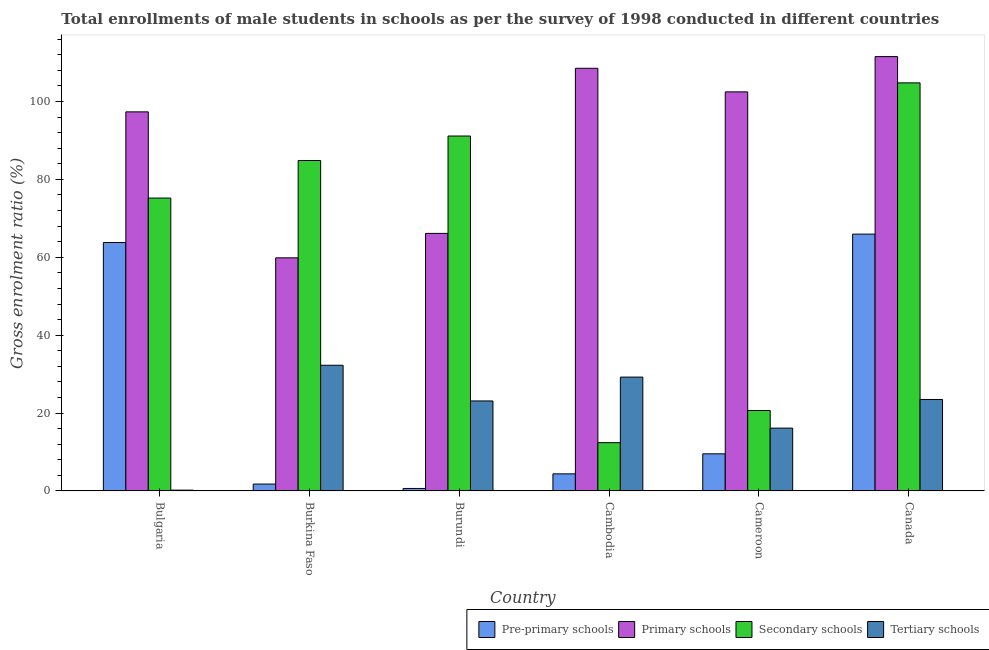How many different coloured bars are there?
Offer a terse response. 4. Are the number of bars on each tick of the X-axis equal?
Your answer should be compact. Yes. How many bars are there on the 3rd tick from the left?
Provide a short and direct response. 4. How many bars are there on the 6th tick from the right?
Your answer should be very brief. 4. What is the label of the 3rd group of bars from the left?
Your response must be concise. Burundi. In how many cases, is the number of bars for a given country not equal to the number of legend labels?
Your answer should be compact. 0. What is the gross enrolment ratio(male) in tertiary schools in Bulgaria?
Your answer should be very brief. 0.2. Across all countries, what is the maximum gross enrolment ratio(male) in tertiary schools?
Offer a very short reply. 32.27. Across all countries, what is the minimum gross enrolment ratio(male) in secondary schools?
Give a very brief answer. 12.4. In which country was the gross enrolment ratio(male) in pre-primary schools minimum?
Give a very brief answer. Burundi. What is the total gross enrolment ratio(male) in primary schools in the graph?
Ensure brevity in your answer.  545.9. What is the difference between the gross enrolment ratio(male) in pre-primary schools in Cambodia and that in Cameroon?
Your answer should be very brief. -5.14. What is the difference between the gross enrolment ratio(male) in pre-primary schools in Cambodia and the gross enrolment ratio(male) in primary schools in Burkina Faso?
Offer a terse response. -55.47. What is the average gross enrolment ratio(male) in tertiary schools per country?
Offer a very short reply. 20.74. What is the difference between the gross enrolment ratio(male) in pre-primary schools and gross enrolment ratio(male) in tertiary schools in Canada?
Offer a very short reply. 42.46. In how many countries, is the gross enrolment ratio(male) in pre-primary schools greater than 24 %?
Give a very brief answer. 2. What is the ratio of the gross enrolment ratio(male) in pre-primary schools in Burundi to that in Cambodia?
Provide a succinct answer. 0.15. Is the difference between the gross enrolment ratio(male) in pre-primary schools in Burundi and Cambodia greater than the difference between the gross enrolment ratio(male) in primary schools in Burundi and Cambodia?
Make the answer very short. Yes. What is the difference between the highest and the second highest gross enrolment ratio(male) in pre-primary schools?
Your answer should be very brief. 2.16. What is the difference between the highest and the lowest gross enrolment ratio(male) in primary schools?
Provide a succinct answer. 51.68. Is the sum of the gross enrolment ratio(male) in secondary schools in Burkina Faso and Burundi greater than the maximum gross enrolment ratio(male) in primary schools across all countries?
Make the answer very short. Yes. Is it the case that in every country, the sum of the gross enrolment ratio(male) in secondary schools and gross enrolment ratio(male) in primary schools is greater than the sum of gross enrolment ratio(male) in tertiary schools and gross enrolment ratio(male) in pre-primary schools?
Keep it short and to the point. No. What does the 1st bar from the left in Burkina Faso represents?
Ensure brevity in your answer.  Pre-primary schools. What does the 2nd bar from the right in Cambodia represents?
Provide a succinct answer. Secondary schools. Is it the case that in every country, the sum of the gross enrolment ratio(male) in pre-primary schools and gross enrolment ratio(male) in primary schools is greater than the gross enrolment ratio(male) in secondary schools?
Offer a very short reply. No. How many bars are there?
Your answer should be very brief. 24. How many countries are there in the graph?
Your answer should be very brief. 6. What is the difference between two consecutive major ticks on the Y-axis?
Make the answer very short. 20. Does the graph contain any zero values?
Ensure brevity in your answer.  No. Does the graph contain grids?
Your answer should be very brief. No. Where does the legend appear in the graph?
Your response must be concise. Bottom right. How many legend labels are there?
Offer a very short reply. 4. How are the legend labels stacked?
Keep it short and to the point. Horizontal. What is the title of the graph?
Your response must be concise. Total enrollments of male students in schools as per the survey of 1998 conducted in different countries. Does "Arable land" appear as one of the legend labels in the graph?
Your response must be concise. No. What is the label or title of the X-axis?
Make the answer very short. Country. What is the label or title of the Y-axis?
Give a very brief answer. Gross enrolment ratio (%). What is the Gross enrolment ratio (%) in Pre-primary schools in Bulgaria?
Provide a short and direct response. 63.8. What is the Gross enrolment ratio (%) of Primary schools in Bulgaria?
Your response must be concise. 97.35. What is the Gross enrolment ratio (%) of Secondary schools in Bulgaria?
Ensure brevity in your answer.  75.21. What is the Gross enrolment ratio (%) of Tertiary schools in Bulgaria?
Provide a short and direct response. 0.2. What is the Gross enrolment ratio (%) of Pre-primary schools in Burkina Faso?
Keep it short and to the point. 1.77. What is the Gross enrolment ratio (%) in Primary schools in Burkina Faso?
Make the answer very short. 59.86. What is the Gross enrolment ratio (%) of Secondary schools in Burkina Faso?
Provide a succinct answer. 84.85. What is the Gross enrolment ratio (%) in Tertiary schools in Burkina Faso?
Provide a succinct answer. 32.27. What is the Gross enrolment ratio (%) of Pre-primary schools in Burundi?
Your response must be concise. 0.64. What is the Gross enrolment ratio (%) of Primary schools in Burundi?
Ensure brevity in your answer.  66.14. What is the Gross enrolment ratio (%) in Secondary schools in Burundi?
Offer a terse response. 91.14. What is the Gross enrolment ratio (%) in Tertiary schools in Burundi?
Provide a short and direct response. 23.11. What is the Gross enrolment ratio (%) of Pre-primary schools in Cambodia?
Offer a terse response. 4.39. What is the Gross enrolment ratio (%) in Primary schools in Cambodia?
Provide a short and direct response. 108.53. What is the Gross enrolment ratio (%) in Secondary schools in Cambodia?
Your response must be concise. 12.4. What is the Gross enrolment ratio (%) of Tertiary schools in Cambodia?
Keep it short and to the point. 29.23. What is the Gross enrolment ratio (%) in Pre-primary schools in Cameroon?
Provide a short and direct response. 9.53. What is the Gross enrolment ratio (%) of Primary schools in Cameroon?
Provide a short and direct response. 102.48. What is the Gross enrolment ratio (%) in Secondary schools in Cameroon?
Your response must be concise. 20.66. What is the Gross enrolment ratio (%) in Tertiary schools in Cameroon?
Offer a terse response. 16.13. What is the Gross enrolment ratio (%) of Pre-primary schools in Canada?
Ensure brevity in your answer.  65.95. What is the Gross enrolment ratio (%) in Primary schools in Canada?
Make the answer very short. 111.54. What is the Gross enrolment ratio (%) of Secondary schools in Canada?
Make the answer very short. 104.79. What is the Gross enrolment ratio (%) of Tertiary schools in Canada?
Give a very brief answer. 23.49. Across all countries, what is the maximum Gross enrolment ratio (%) in Pre-primary schools?
Offer a very short reply. 65.95. Across all countries, what is the maximum Gross enrolment ratio (%) of Primary schools?
Ensure brevity in your answer.  111.54. Across all countries, what is the maximum Gross enrolment ratio (%) in Secondary schools?
Offer a very short reply. 104.79. Across all countries, what is the maximum Gross enrolment ratio (%) of Tertiary schools?
Keep it short and to the point. 32.27. Across all countries, what is the minimum Gross enrolment ratio (%) in Pre-primary schools?
Make the answer very short. 0.64. Across all countries, what is the minimum Gross enrolment ratio (%) in Primary schools?
Ensure brevity in your answer.  59.86. Across all countries, what is the minimum Gross enrolment ratio (%) of Secondary schools?
Give a very brief answer. 12.4. Across all countries, what is the minimum Gross enrolment ratio (%) of Tertiary schools?
Provide a short and direct response. 0.2. What is the total Gross enrolment ratio (%) of Pre-primary schools in the graph?
Provide a short and direct response. 146.08. What is the total Gross enrolment ratio (%) in Primary schools in the graph?
Offer a very short reply. 545.9. What is the total Gross enrolment ratio (%) of Secondary schools in the graph?
Keep it short and to the point. 389.05. What is the total Gross enrolment ratio (%) of Tertiary schools in the graph?
Provide a short and direct response. 124.44. What is the difference between the Gross enrolment ratio (%) of Pre-primary schools in Bulgaria and that in Burkina Faso?
Provide a succinct answer. 62.03. What is the difference between the Gross enrolment ratio (%) of Primary schools in Bulgaria and that in Burkina Faso?
Ensure brevity in your answer.  37.48. What is the difference between the Gross enrolment ratio (%) of Secondary schools in Bulgaria and that in Burkina Faso?
Offer a terse response. -9.64. What is the difference between the Gross enrolment ratio (%) of Tertiary schools in Bulgaria and that in Burkina Faso?
Keep it short and to the point. -32.07. What is the difference between the Gross enrolment ratio (%) of Pre-primary schools in Bulgaria and that in Burundi?
Offer a terse response. 63.16. What is the difference between the Gross enrolment ratio (%) of Primary schools in Bulgaria and that in Burundi?
Ensure brevity in your answer.  31.21. What is the difference between the Gross enrolment ratio (%) of Secondary schools in Bulgaria and that in Burundi?
Offer a very short reply. -15.93. What is the difference between the Gross enrolment ratio (%) of Tertiary schools in Bulgaria and that in Burundi?
Make the answer very short. -22.91. What is the difference between the Gross enrolment ratio (%) in Pre-primary schools in Bulgaria and that in Cambodia?
Your response must be concise. 59.41. What is the difference between the Gross enrolment ratio (%) in Primary schools in Bulgaria and that in Cambodia?
Make the answer very short. -11.19. What is the difference between the Gross enrolment ratio (%) in Secondary schools in Bulgaria and that in Cambodia?
Your response must be concise. 62.82. What is the difference between the Gross enrolment ratio (%) of Tertiary schools in Bulgaria and that in Cambodia?
Your answer should be compact. -29.03. What is the difference between the Gross enrolment ratio (%) in Pre-primary schools in Bulgaria and that in Cameroon?
Provide a succinct answer. 54.26. What is the difference between the Gross enrolment ratio (%) in Primary schools in Bulgaria and that in Cameroon?
Provide a succinct answer. -5.13. What is the difference between the Gross enrolment ratio (%) in Secondary schools in Bulgaria and that in Cameroon?
Your response must be concise. 54.55. What is the difference between the Gross enrolment ratio (%) of Tertiary schools in Bulgaria and that in Cameroon?
Your answer should be very brief. -15.93. What is the difference between the Gross enrolment ratio (%) of Pre-primary schools in Bulgaria and that in Canada?
Offer a terse response. -2.16. What is the difference between the Gross enrolment ratio (%) in Primary schools in Bulgaria and that in Canada?
Offer a terse response. -14.19. What is the difference between the Gross enrolment ratio (%) of Secondary schools in Bulgaria and that in Canada?
Your answer should be compact. -29.58. What is the difference between the Gross enrolment ratio (%) in Tertiary schools in Bulgaria and that in Canada?
Ensure brevity in your answer.  -23.29. What is the difference between the Gross enrolment ratio (%) of Pre-primary schools in Burkina Faso and that in Burundi?
Offer a very short reply. 1.13. What is the difference between the Gross enrolment ratio (%) of Primary schools in Burkina Faso and that in Burundi?
Your answer should be compact. -6.27. What is the difference between the Gross enrolment ratio (%) of Secondary schools in Burkina Faso and that in Burundi?
Offer a terse response. -6.29. What is the difference between the Gross enrolment ratio (%) of Tertiary schools in Burkina Faso and that in Burundi?
Your response must be concise. 9.16. What is the difference between the Gross enrolment ratio (%) of Pre-primary schools in Burkina Faso and that in Cambodia?
Your answer should be compact. -2.62. What is the difference between the Gross enrolment ratio (%) of Primary schools in Burkina Faso and that in Cambodia?
Make the answer very short. -48.67. What is the difference between the Gross enrolment ratio (%) in Secondary schools in Burkina Faso and that in Cambodia?
Your response must be concise. 72.46. What is the difference between the Gross enrolment ratio (%) in Tertiary schools in Burkina Faso and that in Cambodia?
Your answer should be compact. 3.04. What is the difference between the Gross enrolment ratio (%) of Pre-primary schools in Burkina Faso and that in Cameroon?
Offer a very short reply. -7.77. What is the difference between the Gross enrolment ratio (%) in Primary schools in Burkina Faso and that in Cameroon?
Your response must be concise. -42.62. What is the difference between the Gross enrolment ratio (%) in Secondary schools in Burkina Faso and that in Cameroon?
Your response must be concise. 64.2. What is the difference between the Gross enrolment ratio (%) of Tertiary schools in Burkina Faso and that in Cameroon?
Keep it short and to the point. 16.14. What is the difference between the Gross enrolment ratio (%) of Pre-primary schools in Burkina Faso and that in Canada?
Give a very brief answer. -64.18. What is the difference between the Gross enrolment ratio (%) in Primary schools in Burkina Faso and that in Canada?
Offer a terse response. -51.68. What is the difference between the Gross enrolment ratio (%) in Secondary schools in Burkina Faso and that in Canada?
Offer a very short reply. -19.94. What is the difference between the Gross enrolment ratio (%) of Tertiary schools in Burkina Faso and that in Canada?
Your response must be concise. 8.79. What is the difference between the Gross enrolment ratio (%) in Pre-primary schools in Burundi and that in Cambodia?
Make the answer very short. -3.75. What is the difference between the Gross enrolment ratio (%) in Primary schools in Burundi and that in Cambodia?
Give a very brief answer. -42.4. What is the difference between the Gross enrolment ratio (%) of Secondary schools in Burundi and that in Cambodia?
Ensure brevity in your answer.  78.74. What is the difference between the Gross enrolment ratio (%) in Tertiary schools in Burundi and that in Cambodia?
Give a very brief answer. -6.12. What is the difference between the Gross enrolment ratio (%) in Pre-primary schools in Burundi and that in Cameroon?
Your answer should be very brief. -8.9. What is the difference between the Gross enrolment ratio (%) in Primary schools in Burundi and that in Cameroon?
Your answer should be very brief. -36.34. What is the difference between the Gross enrolment ratio (%) of Secondary schools in Burundi and that in Cameroon?
Your answer should be very brief. 70.48. What is the difference between the Gross enrolment ratio (%) of Tertiary schools in Burundi and that in Cameroon?
Provide a short and direct response. 6.98. What is the difference between the Gross enrolment ratio (%) of Pre-primary schools in Burundi and that in Canada?
Offer a very short reply. -65.31. What is the difference between the Gross enrolment ratio (%) of Primary schools in Burundi and that in Canada?
Provide a succinct answer. -45.4. What is the difference between the Gross enrolment ratio (%) of Secondary schools in Burundi and that in Canada?
Offer a terse response. -13.65. What is the difference between the Gross enrolment ratio (%) in Tertiary schools in Burundi and that in Canada?
Keep it short and to the point. -0.38. What is the difference between the Gross enrolment ratio (%) of Pre-primary schools in Cambodia and that in Cameroon?
Provide a succinct answer. -5.14. What is the difference between the Gross enrolment ratio (%) of Primary schools in Cambodia and that in Cameroon?
Offer a very short reply. 6.05. What is the difference between the Gross enrolment ratio (%) of Secondary schools in Cambodia and that in Cameroon?
Offer a terse response. -8.26. What is the difference between the Gross enrolment ratio (%) of Tertiary schools in Cambodia and that in Cameroon?
Give a very brief answer. 13.1. What is the difference between the Gross enrolment ratio (%) of Pre-primary schools in Cambodia and that in Canada?
Provide a succinct answer. -61.56. What is the difference between the Gross enrolment ratio (%) of Primary schools in Cambodia and that in Canada?
Your answer should be compact. -3. What is the difference between the Gross enrolment ratio (%) of Secondary schools in Cambodia and that in Canada?
Offer a very short reply. -92.4. What is the difference between the Gross enrolment ratio (%) of Tertiary schools in Cambodia and that in Canada?
Make the answer very short. 5.74. What is the difference between the Gross enrolment ratio (%) in Pre-primary schools in Cameroon and that in Canada?
Ensure brevity in your answer.  -56.42. What is the difference between the Gross enrolment ratio (%) of Primary schools in Cameroon and that in Canada?
Keep it short and to the point. -9.06. What is the difference between the Gross enrolment ratio (%) of Secondary schools in Cameroon and that in Canada?
Offer a very short reply. -84.13. What is the difference between the Gross enrolment ratio (%) of Tertiary schools in Cameroon and that in Canada?
Your response must be concise. -7.36. What is the difference between the Gross enrolment ratio (%) in Pre-primary schools in Bulgaria and the Gross enrolment ratio (%) in Primary schools in Burkina Faso?
Offer a terse response. 3.94. What is the difference between the Gross enrolment ratio (%) of Pre-primary schools in Bulgaria and the Gross enrolment ratio (%) of Secondary schools in Burkina Faso?
Make the answer very short. -21.06. What is the difference between the Gross enrolment ratio (%) in Pre-primary schools in Bulgaria and the Gross enrolment ratio (%) in Tertiary schools in Burkina Faso?
Keep it short and to the point. 31.52. What is the difference between the Gross enrolment ratio (%) of Primary schools in Bulgaria and the Gross enrolment ratio (%) of Secondary schools in Burkina Faso?
Your response must be concise. 12.49. What is the difference between the Gross enrolment ratio (%) of Primary schools in Bulgaria and the Gross enrolment ratio (%) of Tertiary schools in Burkina Faso?
Keep it short and to the point. 65.07. What is the difference between the Gross enrolment ratio (%) of Secondary schools in Bulgaria and the Gross enrolment ratio (%) of Tertiary schools in Burkina Faso?
Provide a short and direct response. 42.94. What is the difference between the Gross enrolment ratio (%) of Pre-primary schools in Bulgaria and the Gross enrolment ratio (%) of Primary schools in Burundi?
Make the answer very short. -2.34. What is the difference between the Gross enrolment ratio (%) in Pre-primary schools in Bulgaria and the Gross enrolment ratio (%) in Secondary schools in Burundi?
Provide a short and direct response. -27.34. What is the difference between the Gross enrolment ratio (%) in Pre-primary schools in Bulgaria and the Gross enrolment ratio (%) in Tertiary schools in Burundi?
Offer a very short reply. 40.69. What is the difference between the Gross enrolment ratio (%) of Primary schools in Bulgaria and the Gross enrolment ratio (%) of Secondary schools in Burundi?
Give a very brief answer. 6.21. What is the difference between the Gross enrolment ratio (%) in Primary schools in Bulgaria and the Gross enrolment ratio (%) in Tertiary schools in Burundi?
Provide a succinct answer. 74.24. What is the difference between the Gross enrolment ratio (%) in Secondary schools in Bulgaria and the Gross enrolment ratio (%) in Tertiary schools in Burundi?
Your response must be concise. 52.1. What is the difference between the Gross enrolment ratio (%) of Pre-primary schools in Bulgaria and the Gross enrolment ratio (%) of Primary schools in Cambodia?
Make the answer very short. -44.74. What is the difference between the Gross enrolment ratio (%) in Pre-primary schools in Bulgaria and the Gross enrolment ratio (%) in Secondary schools in Cambodia?
Provide a succinct answer. 51.4. What is the difference between the Gross enrolment ratio (%) of Pre-primary schools in Bulgaria and the Gross enrolment ratio (%) of Tertiary schools in Cambodia?
Offer a very short reply. 34.57. What is the difference between the Gross enrolment ratio (%) of Primary schools in Bulgaria and the Gross enrolment ratio (%) of Secondary schools in Cambodia?
Provide a succinct answer. 84.95. What is the difference between the Gross enrolment ratio (%) of Primary schools in Bulgaria and the Gross enrolment ratio (%) of Tertiary schools in Cambodia?
Give a very brief answer. 68.11. What is the difference between the Gross enrolment ratio (%) in Secondary schools in Bulgaria and the Gross enrolment ratio (%) in Tertiary schools in Cambodia?
Ensure brevity in your answer.  45.98. What is the difference between the Gross enrolment ratio (%) of Pre-primary schools in Bulgaria and the Gross enrolment ratio (%) of Primary schools in Cameroon?
Your answer should be compact. -38.68. What is the difference between the Gross enrolment ratio (%) of Pre-primary schools in Bulgaria and the Gross enrolment ratio (%) of Secondary schools in Cameroon?
Your answer should be compact. 43.14. What is the difference between the Gross enrolment ratio (%) of Pre-primary schools in Bulgaria and the Gross enrolment ratio (%) of Tertiary schools in Cameroon?
Provide a succinct answer. 47.67. What is the difference between the Gross enrolment ratio (%) of Primary schools in Bulgaria and the Gross enrolment ratio (%) of Secondary schools in Cameroon?
Provide a short and direct response. 76.69. What is the difference between the Gross enrolment ratio (%) of Primary schools in Bulgaria and the Gross enrolment ratio (%) of Tertiary schools in Cameroon?
Your answer should be compact. 81.21. What is the difference between the Gross enrolment ratio (%) in Secondary schools in Bulgaria and the Gross enrolment ratio (%) in Tertiary schools in Cameroon?
Provide a succinct answer. 59.08. What is the difference between the Gross enrolment ratio (%) in Pre-primary schools in Bulgaria and the Gross enrolment ratio (%) in Primary schools in Canada?
Provide a short and direct response. -47.74. What is the difference between the Gross enrolment ratio (%) in Pre-primary schools in Bulgaria and the Gross enrolment ratio (%) in Secondary schools in Canada?
Provide a succinct answer. -40.99. What is the difference between the Gross enrolment ratio (%) of Pre-primary schools in Bulgaria and the Gross enrolment ratio (%) of Tertiary schools in Canada?
Provide a short and direct response. 40.31. What is the difference between the Gross enrolment ratio (%) of Primary schools in Bulgaria and the Gross enrolment ratio (%) of Secondary schools in Canada?
Ensure brevity in your answer.  -7.45. What is the difference between the Gross enrolment ratio (%) of Primary schools in Bulgaria and the Gross enrolment ratio (%) of Tertiary schools in Canada?
Provide a short and direct response. 73.86. What is the difference between the Gross enrolment ratio (%) of Secondary schools in Bulgaria and the Gross enrolment ratio (%) of Tertiary schools in Canada?
Keep it short and to the point. 51.72. What is the difference between the Gross enrolment ratio (%) in Pre-primary schools in Burkina Faso and the Gross enrolment ratio (%) in Primary schools in Burundi?
Ensure brevity in your answer.  -64.37. What is the difference between the Gross enrolment ratio (%) of Pre-primary schools in Burkina Faso and the Gross enrolment ratio (%) of Secondary schools in Burundi?
Provide a succinct answer. -89.37. What is the difference between the Gross enrolment ratio (%) of Pre-primary schools in Burkina Faso and the Gross enrolment ratio (%) of Tertiary schools in Burundi?
Give a very brief answer. -21.34. What is the difference between the Gross enrolment ratio (%) in Primary schools in Burkina Faso and the Gross enrolment ratio (%) in Secondary schools in Burundi?
Provide a short and direct response. -31.28. What is the difference between the Gross enrolment ratio (%) in Primary schools in Burkina Faso and the Gross enrolment ratio (%) in Tertiary schools in Burundi?
Your response must be concise. 36.75. What is the difference between the Gross enrolment ratio (%) in Secondary schools in Burkina Faso and the Gross enrolment ratio (%) in Tertiary schools in Burundi?
Offer a terse response. 61.74. What is the difference between the Gross enrolment ratio (%) in Pre-primary schools in Burkina Faso and the Gross enrolment ratio (%) in Primary schools in Cambodia?
Ensure brevity in your answer.  -106.77. What is the difference between the Gross enrolment ratio (%) of Pre-primary schools in Burkina Faso and the Gross enrolment ratio (%) of Secondary schools in Cambodia?
Make the answer very short. -10.63. What is the difference between the Gross enrolment ratio (%) of Pre-primary schools in Burkina Faso and the Gross enrolment ratio (%) of Tertiary schools in Cambodia?
Offer a very short reply. -27.46. What is the difference between the Gross enrolment ratio (%) in Primary schools in Burkina Faso and the Gross enrolment ratio (%) in Secondary schools in Cambodia?
Make the answer very short. 47.47. What is the difference between the Gross enrolment ratio (%) of Primary schools in Burkina Faso and the Gross enrolment ratio (%) of Tertiary schools in Cambodia?
Offer a very short reply. 30.63. What is the difference between the Gross enrolment ratio (%) of Secondary schools in Burkina Faso and the Gross enrolment ratio (%) of Tertiary schools in Cambodia?
Provide a succinct answer. 55.62. What is the difference between the Gross enrolment ratio (%) in Pre-primary schools in Burkina Faso and the Gross enrolment ratio (%) in Primary schools in Cameroon?
Make the answer very short. -100.71. What is the difference between the Gross enrolment ratio (%) in Pre-primary schools in Burkina Faso and the Gross enrolment ratio (%) in Secondary schools in Cameroon?
Offer a terse response. -18.89. What is the difference between the Gross enrolment ratio (%) in Pre-primary schools in Burkina Faso and the Gross enrolment ratio (%) in Tertiary schools in Cameroon?
Offer a terse response. -14.36. What is the difference between the Gross enrolment ratio (%) of Primary schools in Burkina Faso and the Gross enrolment ratio (%) of Secondary schools in Cameroon?
Ensure brevity in your answer.  39.2. What is the difference between the Gross enrolment ratio (%) of Primary schools in Burkina Faso and the Gross enrolment ratio (%) of Tertiary schools in Cameroon?
Your answer should be very brief. 43.73. What is the difference between the Gross enrolment ratio (%) of Secondary schools in Burkina Faso and the Gross enrolment ratio (%) of Tertiary schools in Cameroon?
Offer a very short reply. 68.72. What is the difference between the Gross enrolment ratio (%) in Pre-primary schools in Burkina Faso and the Gross enrolment ratio (%) in Primary schools in Canada?
Offer a terse response. -109.77. What is the difference between the Gross enrolment ratio (%) of Pre-primary schools in Burkina Faso and the Gross enrolment ratio (%) of Secondary schools in Canada?
Your response must be concise. -103.02. What is the difference between the Gross enrolment ratio (%) in Pre-primary schools in Burkina Faso and the Gross enrolment ratio (%) in Tertiary schools in Canada?
Offer a terse response. -21.72. What is the difference between the Gross enrolment ratio (%) of Primary schools in Burkina Faso and the Gross enrolment ratio (%) of Secondary schools in Canada?
Offer a terse response. -44.93. What is the difference between the Gross enrolment ratio (%) in Primary schools in Burkina Faso and the Gross enrolment ratio (%) in Tertiary schools in Canada?
Provide a short and direct response. 36.37. What is the difference between the Gross enrolment ratio (%) of Secondary schools in Burkina Faso and the Gross enrolment ratio (%) of Tertiary schools in Canada?
Provide a short and direct response. 61.37. What is the difference between the Gross enrolment ratio (%) in Pre-primary schools in Burundi and the Gross enrolment ratio (%) in Primary schools in Cambodia?
Give a very brief answer. -107.9. What is the difference between the Gross enrolment ratio (%) in Pre-primary schools in Burundi and the Gross enrolment ratio (%) in Secondary schools in Cambodia?
Provide a succinct answer. -11.76. What is the difference between the Gross enrolment ratio (%) of Pre-primary schools in Burundi and the Gross enrolment ratio (%) of Tertiary schools in Cambodia?
Give a very brief answer. -28.59. What is the difference between the Gross enrolment ratio (%) of Primary schools in Burundi and the Gross enrolment ratio (%) of Secondary schools in Cambodia?
Keep it short and to the point. 53.74. What is the difference between the Gross enrolment ratio (%) in Primary schools in Burundi and the Gross enrolment ratio (%) in Tertiary schools in Cambodia?
Offer a very short reply. 36.9. What is the difference between the Gross enrolment ratio (%) in Secondary schools in Burundi and the Gross enrolment ratio (%) in Tertiary schools in Cambodia?
Your response must be concise. 61.91. What is the difference between the Gross enrolment ratio (%) in Pre-primary schools in Burundi and the Gross enrolment ratio (%) in Primary schools in Cameroon?
Ensure brevity in your answer.  -101.84. What is the difference between the Gross enrolment ratio (%) of Pre-primary schools in Burundi and the Gross enrolment ratio (%) of Secondary schools in Cameroon?
Your response must be concise. -20.02. What is the difference between the Gross enrolment ratio (%) of Pre-primary schools in Burundi and the Gross enrolment ratio (%) of Tertiary schools in Cameroon?
Your answer should be compact. -15.49. What is the difference between the Gross enrolment ratio (%) in Primary schools in Burundi and the Gross enrolment ratio (%) in Secondary schools in Cameroon?
Provide a short and direct response. 45.48. What is the difference between the Gross enrolment ratio (%) of Primary schools in Burundi and the Gross enrolment ratio (%) of Tertiary schools in Cameroon?
Your response must be concise. 50. What is the difference between the Gross enrolment ratio (%) in Secondary schools in Burundi and the Gross enrolment ratio (%) in Tertiary schools in Cameroon?
Ensure brevity in your answer.  75.01. What is the difference between the Gross enrolment ratio (%) in Pre-primary schools in Burundi and the Gross enrolment ratio (%) in Primary schools in Canada?
Offer a terse response. -110.9. What is the difference between the Gross enrolment ratio (%) in Pre-primary schools in Burundi and the Gross enrolment ratio (%) in Secondary schools in Canada?
Give a very brief answer. -104.15. What is the difference between the Gross enrolment ratio (%) in Pre-primary schools in Burundi and the Gross enrolment ratio (%) in Tertiary schools in Canada?
Offer a very short reply. -22.85. What is the difference between the Gross enrolment ratio (%) in Primary schools in Burundi and the Gross enrolment ratio (%) in Secondary schools in Canada?
Your response must be concise. -38.66. What is the difference between the Gross enrolment ratio (%) of Primary schools in Burundi and the Gross enrolment ratio (%) of Tertiary schools in Canada?
Provide a succinct answer. 42.65. What is the difference between the Gross enrolment ratio (%) of Secondary schools in Burundi and the Gross enrolment ratio (%) of Tertiary schools in Canada?
Your answer should be compact. 67.65. What is the difference between the Gross enrolment ratio (%) in Pre-primary schools in Cambodia and the Gross enrolment ratio (%) in Primary schools in Cameroon?
Your answer should be very brief. -98.09. What is the difference between the Gross enrolment ratio (%) of Pre-primary schools in Cambodia and the Gross enrolment ratio (%) of Secondary schools in Cameroon?
Your answer should be very brief. -16.27. What is the difference between the Gross enrolment ratio (%) in Pre-primary schools in Cambodia and the Gross enrolment ratio (%) in Tertiary schools in Cameroon?
Your answer should be compact. -11.74. What is the difference between the Gross enrolment ratio (%) of Primary schools in Cambodia and the Gross enrolment ratio (%) of Secondary schools in Cameroon?
Offer a terse response. 87.88. What is the difference between the Gross enrolment ratio (%) of Primary schools in Cambodia and the Gross enrolment ratio (%) of Tertiary schools in Cameroon?
Your response must be concise. 92.4. What is the difference between the Gross enrolment ratio (%) in Secondary schools in Cambodia and the Gross enrolment ratio (%) in Tertiary schools in Cameroon?
Provide a short and direct response. -3.74. What is the difference between the Gross enrolment ratio (%) in Pre-primary schools in Cambodia and the Gross enrolment ratio (%) in Primary schools in Canada?
Ensure brevity in your answer.  -107.15. What is the difference between the Gross enrolment ratio (%) of Pre-primary schools in Cambodia and the Gross enrolment ratio (%) of Secondary schools in Canada?
Make the answer very short. -100.4. What is the difference between the Gross enrolment ratio (%) of Pre-primary schools in Cambodia and the Gross enrolment ratio (%) of Tertiary schools in Canada?
Offer a very short reply. -19.1. What is the difference between the Gross enrolment ratio (%) in Primary schools in Cambodia and the Gross enrolment ratio (%) in Secondary schools in Canada?
Provide a short and direct response. 3.74. What is the difference between the Gross enrolment ratio (%) in Primary schools in Cambodia and the Gross enrolment ratio (%) in Tertiary schools in Canada?
Provide a short and direct response. 85.05. What is the difference between the Gross enrolment ratio (%) of Secondary schools in Cambodia and the Gross enrolment ratio (%) of Tertiary schools in Canada?
Ensure brevity in your answer.  -11.09. What is the difference between the Gross enrolment ratio (%) in Pre-primary schools in Cameroon and the Gross enrolment ratio (%) in Primary schools in Canada?
Provide a short and direct response. -102.01. What is the difference between the Gross enrolment ratio (%) of Pre-primary schools in Cameroon and the Gross enrolment ratio (%) of Secondary schools in Canada?
Your answer should be very brief. -95.26. What is the difference between the Gross enrolment ratio (%) in Pre-primary schools in Cameroon and the Gross enrolment ratio (%) in Tertiary schools in Canada?
Give a very brief answer. -13.95. What is the difference between the Gross enrolment ratio (%) of Primary schools in Cameroon and the Gross enrolment ratio (%) of Secondary schools in Canada?
Give a very brief answer. -2.31. What is the difference between the Gross enrolment ratio (%) in Primary schools in Cameroon and the Gross enrolment ratio (%) in Tertiary schools in Canada?
Ensure brevity in your answer.  78.99. What is the difference between the Gross enrolment ratio (%) of Secondary schools in Cameroon and the Gross enrolment ratio (%) of Tertiary schools in Canada?
Ensure brevity in your answer.  -2.83. What is the average Gross enrolment ratio (%) of Pre-primary schools per country?
Provide a succinct answer. 24.35. What is the average Gross enrolment ratio (%) of Primary schools per country?
Provide a succinct answer. 90.98. What is the average Gross enrolment ratio (%) of Secondary schools per country?
Keep it short and to the point. 64.84. What is the average Gross enrolment ratio (%) in Tertiary schools per country?
Ensure brevity in your answer.  20.74. What is the difference between the Gross enrolment ratio (%) of Pre-primary schools and Gross enrolment ratio (%) of Primary schools in Bulgaria?
Give a very brief answer. -33.55. What is the difference between the Gross enrolment ratio (%) of Pre-primary schools and Gross enrolment ratio (%) of Secondary schools in Bulgaria?
Your answer should be compact. -11.41. What is the difference between the Gross enrolment ratio (%) of Pre-primary schools and Gross enrolment ratio (%) of Tertiary schools in Bulgaria?
Your answer should be compact. 63.59. What is the difference between the Gross enrolment ratio (%) in Primary schools and Gross enrolment ratio (%) in Secondary schools in Bulgaria?
Make the answer very short. 22.13. What is the difference between the Gross enrolment ratio (%) in Primary schools and Gross enrolment ratio (%) in Tertiary schools in Bulgaria?
Offer a very short reply. 97.14. What is the difference between the Gross enrolment ratio (%) in Secondary schools and Gross enrolment ratio (%) in Tertiary schools in Bulgaria?
Your answer should be compact. 75.01. What is the difference between the Gross enrolment ratio (%) in Pre-primary schools and Gross enrolment ratio (%) in Primary schools in Burkina Faso?
Your response must be concise. -58.09. What is the difference between the Gross enrolment ratio (%) in Pre-primary schools and Gross enrolment ratio (%) in Secondary schools in Burkina Faso?
Your answer should be compact. -83.09. What is the difference between the Gross enrolment ratio (%) of Pre-primary schools and Gross enrolment ratio (%) of Tertiary schools in Burkina Faso?
Offer a very short reply. -30.51. What is the difference between the Gross enrolment ratio (%) of Primary schools and Gross enrolment ratio (%) of Secondary schools in Burkina Faso?
Offer a terse response. -24.99. What is the difference between the Gross enrolment ratio (%) in Primary schools and Gross enrolment ratio (%) in Tertiary schools in Burkina Faso?
Keep it short and to the point. 27.59. What is the difference between the Gross enrolment ratio (%) of Secondary schools and Gross enrolment ratio (%) of Tertiary schools in Burkina Faso?
Keep it short and to the point. 52.58. What is the difference between the Gross enrolment ratio (%) of Pre-primary schools and Gross enrolment ratio (%) of Primary schools in Burundi?
Offer a very short reply. -65.5. What is the difference between the Gross enrolment ratio (%) of Pre-primary schools and Gross enrolment ratio (%) of Secondary schools in Burundi?
Ensure brevity in your answer.  -90.5. What is the difference between the Gross enrolment ratio (%) of Pre-primary schools and Gross enrolment ratio (%) of Tertiary schools in Burundi?
Offer a terse response. -22.47. What is the difference between the Gross enrolment ratio (%) of Primary schools and Gross enrolment ratio (%) of Secondary schools in Burundi?
Offer a terse response. -25. What is the difference between the Gross enrolment ratio (%) in Primary schools and Gross enrolment ratio (%) in Tertiary schools in Burundi?
Your answer should be very brief. 43.03. What is the difference between the Gross enrolment ratio (%) of Secondary schools and Gross enrolment ratio (%) of Tertiary schools in Burundi?
Your answer should be compact. 68.03. What is the difference between the Gross enrolment ratio (%) of Pre-primary schools and Gross enrolment ratio (%) of Primary schools in Cambodia?
Offer a terse response. -104.15. What is the difference between the Gross enrolment ratio (%) in Pre-primary schools and Gross enrolment ratio (%) in Secondary schools in Cambodia?
Provide a short and direct response. -8.01. What is the difference between the Gross enrolment ratio (%) of Pre-primary schools and Gross enrolment ratio (%) of Tertiary schools in Cambodia?
Your response must be concise. -24.84. What is the difference between the Gross enrolment ratio (%) in Primary schools and Gross enrolment ratio (%) in Secondary schools in Cambodia?
Provide a short and direct response. 96.14. What is the difference between the Gross enrolment ratio (%) in Primary schools and Gross enrolment ratio (%) in Tertiary schools in Cambodia?
Offer a terse response. 79.3. What is the difference between the Gross enrolment ratio (%) in Secondary schools and Gross enrolment ratio (%) in Tertiary schools in Cambodia?
Give a very brief answer. -16.84. What is the difference between the Gross enrolment ratio (%) of Pre-primary schools and Gross enrolment ratio (%) of Primary schools in Cameroon?
Provide a succinct answer. -92.95. What is the difference between the Gross enrolment ratio (%) of Pre-primary schools and Gross enrolment ratio (%) of Secondary schools in Cameroon?
Provide a short and direct response. -11.12. What is the difference between the Gross enrolment ratio (%) of Pre-primary schools and Gross enrolment ratio (%) of Tertiary schools in Cameroon?
Offer a terse response. -6.6. What is the difference between the Gross enrolment ratio (%) of Primary schools and Gross enrolment ratio (%) of Secondary schools in Cameroon?
Your response must be concise. 81.82. What is the difference between the Gross enrolment ratio (%) of Primary schools and Gross enrolment ratio (%) of Tertiary schools in Cameroon?
Offer a very short reply. 86.35. What is the difference between the Gross enrolment ratio (%) in Secondary schools and Gross enrolment ratio (%) in Tertiary schools in Cameroon?
Make the answer very short. 4.53. What is the difference between the Gross enrolment ratio (%) of Pre-primary schools and Gross enrolment ratio (%) of Primary schools in Canada?
Ensure brevity in your answer.  -45.59. What is the difference between the Gross enrolment ratio (%) of Pre-primary schools and Gross enrolment ratio (%) of Secondary schools in Canada?
Your response must be concise. -38.84. What is the difference between the Gross enrolment ratio (%) in Pre-primary schools and Gross enrolment ratio (%) in Tertiary schools in Canada?
Provide a succinct answer. 42.46. What is the difference between the Gross enrolment ratio (%) in Primary schools and Gross enrolment ratio (%) in Secondary schools in Canada?
Give a very brief answer. 6.75. What is the difference between the Gross enrolment ratio (%) in Primary schools and Gross enrolment ratio (%) in Tertiary schools in Canada?
Ensure brevity in your answer.  88.05. What is the difference between the Gross enrolment ratio (%) in Secondary schools and Gross enrolment ratio (%) in Tertiary schools in Canada?
Make the answer very short. 81.3. What is the ratio of the Gross enrolment ratio (%) of Pre-primary schools in Bulgaria to that in Burkina Faso?
Ensure brevity in your answer.  36.1. What is the ratio of the Gross enrolment ratio (%) in Primary schools in Bulgaria to that in Burkina Faso?
Offer a very short reply. 1.63. What is the ratio of the Gross enrolment ratio (%) in Secondary schools in Bulgaria to that in Burkina Faso?
Your answer should be very brief. 0.89. What is the ratio of the Gross enrolment ratio (%) of Tertiary schools in Bulgaria to that in Burkina Faso?
Your response must be concise. 0.01. What is the ratio of the Gross enrolment ratio (%) of Pre-primary schools in Bulgaria to that in Burundi?
Your answer should be compact. 100.1. What is the ratio of the Gross enrolment ratio (%) of Primary schools in Bulgaria to that in Burundi?
Your answer should be compact. 1.47. What is the ratio of the Gross enrolment ratio (%) in Secondary schools in Bulgaria to that in Burundi?
Your answer should be very brief. 0.83. What is the ratio of the Gross enrolment ratio (%) of Tertiary schools in Bulgaria to that in Burundi?
Make the answer very short. 0.01. What is the ratio of the Gross enrolment ratio (%) in Pre-primary schools in Bulgaria to that in Cambodia?
Offer a very short reply. 14.53. What is the ratio of the Gross enrolment ratio (%) in Primary schools in Bulgaria to that in Cambodia?
Ensure brevity in your answer.  0.9. What is the ratio of the Gross enrolment ratio (%) of Secondary schools in Bulgaria to that in Cambodia?
Offer a terse response. 6.07. What is the ratio of the Gross enrolment ratio (%) in Tertiary schools in Bulgaria to that in Cambodia?
Provide a short and direct response. 0.01. What is the ratio of the Gross enrolment ratio (%) in Pre-primary schools in Bulgaria to that in Cameroon?
Your response must be concise. 6.69. What is the ratio of the Gross enrolment ratio (%) in Primary schools in Bulgaria to that in Cameroon?
Your response must be concise. 0.95. What is the ratio of the Gross enrolment ratio (%) in Secondary schools in Bulgaria to that in Cameroon?
Provide a succinct answer. 3.64. What is the ratio of the Gross enrolment ratio (%) of Tertiary schools in Bulgaria to that in Cameroon?
Provide a short and direct response. 0.01. What is the ratio of the Gross enrolment ratio (%) in Pre-primary schools in Bulgaria to that in Canada?
Offer a very short reply. 0.97. What is the ratio of the Gross enrolment ratio (%) of Primary schools in Bulgaria to that in Canada?
Make the answer very short. 0.87. What is the ratio of the Gross enrolment ratio (%) of Secondary schools in Bulgaria to that in Canada?
Your answer should be very brief. 0.72. What is the ratio of the Gross enrolment ratio (%) in Tertiary schools in Bulgaria to that in Canada?
Keep it short and to the point. 0.01. What is the ratio of the Gross enrolment ratio (%) in Pre-primary schools in Burkina Faso to that in Burundi?
Keep it short and to the point. 2.77. What is the ratio of the Gross enrolment ratio (%) in Primary schools in Burkina Faso to that in Burundi?
Your response must be concise. 0.91. What is the ratio of the Gross enrolment ratio (%) of Tertiary schools in Burkina Faso to that in Burundi?
Provide a succinct answer. 1.4. What is the ratio of the Gross enrolment ratio (%) of Pre-primary schools in Burkina Faso to that in Cambodia?
Your answer should be very brief. 0.4. What is the ratio of the Gross enrolment ratio (%) of Primary schools in Burkina Faso to that in Cambodia?
Your answer should be compact. 0.55. What is the ratio of the Gross enrolment ratio (%) of Secondary schools in Burkina Faso to that in Cambodia?
Your response must be concise. 6.85. What is the ratio of the Gross enrolment ratio (%) of Tertiary schools in Burkina Faso to that in Cambodia?
Ensure brevity in your answer.  1.1. What is the ratio of the Gross enrolment ratio (%) in Pre-primary schools in Burkina Faso to that in Cameroon?
Your answer should be very brief. 0.19. What is the ratio of the Gross enrolment ratio (%) of Primary schools in Burkina Faso to that in Cameroon?
Give a very brief answer. 0.58. What is the ratio of the Gross enrolment ratio (%) of Secondary schools in Burkina Faso to that in Cameroon?
Offer a very short reply. 4.11. What is the ratio of the Gross enrolment ratio (%) in Tertiary schools in Burkina Faso to that in Cameroon?
Your answer should be very brief. 2. What is the ratio of the Gross enrolment ratio (%) of Pre-primary schools in Burkina Faso to that in Canada?
Your answer should be compact. 0.03. What is the ratio of the Gross enrolment ratio (%) of Primary schools in Burkina Faso to that in Canada?
Make the answer very short. 0.54. What is the ratio of the Gross enrolment ratio (%) of Secondary schools in Burkina Faso to that in Canada?
Make the answer very short. 0.81. What is the ratio of the Gross enrolment ratio (%) of Tertiary schools in Burkina Faso to that in Canada?
Ensure brevity in your answer.  1.37. What is the ratio of the Gross enrolment ratio (%) of Pre-primary schools in Burundi to that in Cambodia?
Your answer should be compact. 0.15. What is the ratio of the Gross enrolment ratio (%) in Primary schools in Burundi to that in Cambodia?
Give a very brief answer. 0.61. What is the ratio of the Gross enrolment ratio (%) of Secondary schools in Burundi to that in Cambodia?
Ensure brevity in your answer.  7.35. What is the ratio of the Gross enrolment ratio (%) in Tertiary schools in Burundi to that in Cambodia?
Give a very brief answer. 0.79. What is the ratio of the Gross enrolment ratio (%) of Pre-primary schools in Burundi to that in Cameroon?
Give a very brief answer. 0.07. What is the ratio of the Gross enrolment ratio (%) in Primary schools in Burundi to that in Cameroon?
Offer a terse response. 0.65. What is the ratio of the Gross enrolment ratio (%) of Secondary schools in Burundi to that in Cameroon?
Provide a short and direct response. 4.41. What is the ratio of the Gross enrolment ratio (%) in Tertiary schools in Burundi to that in Cameroon?
Give a very brief answer. 1.43. What is the ratio of the Gross enrolment ratio (%) in Pre-primary schools in Burundi to that in Canada?
Offer a terse response. 0.01. What is the ratio of the Gross enrolment ratio (%) in Primary schools in Burundi to that in Canada?
Offer a very short reply. 0.59. What is the ratio of the Gross enrolment ratio (%) of Secondary schools in Burundi to that in Canada?
Provide a succinct answer. 0.87. What is the ratio of the Gross enrolment ratio (%) of Tertiary schools in Burundi to that in Canada?
Offer a very short reply. 0.98. What is the ratio of the Gross enrolment ratio (%) of Pre-primary schools in Cambodia to that in Cameroon?
Your answer should be very brief. 0.46. What is the ratio of the Gross enrolment ratio (%) in Primary schools in Cambodia to that in Cameroon?
Keep it short and to the point. 1.06. What is the ratio of the Gross enrolment ratio (%) of Secondary schools in Cambodia to that in Cameroon?
Offer a terse response. 0.6. What is the ratio of the Gross enrolment ratio (%) in Tertiary schools in Cambodia to that in Cameroon?
Offer a very short reply. 1.81. What is the ratio of the Gross enrolment ratio (%) of Pre-primary schools in Cambodia to that in Canada?
Your answer should be compact. 0.07. What is the ratio of the Gross enrolment ratio (%) in Primary schools in Cambodia to that in Canada?
Provide a succinct answer. 0.97. What is the ratio of the Gross enrolment ratio (%) of Secondary schools in Cambodia to that in Canada?
Your response must be concise. 0.12. What is the ratio of the Gross enrolment ratio (%) in Tertiary schools in Cambodia to that in Canada?
Provide a succinct answer. 1.24. What is the ratio of the Gross enrolment ratio (%) in Pre-primary schools in Cameroon to that in Canada?
Your answer should be compact. 0.14. What is the ratio of the Gross enrolment ratio (%) of Primary schools in Cameroon to that in Canada?
Make the answer very short. 0.92. What is the ratio of the Gross enrolment ratio (%) in Secondary schools in Cameroon to that in Canada?
Offer a very short reply. 0.2. What is the ratio of the Gross enrolment ratio (%) of Tertiary schools in Cameroon to that in Canada?
Your response must be concise. 0.69. What is the difference between the highest and the second highest Gross enrolment ratio (%) in Pre-primary schools?
Your answer should be compact. 2.16. What is the difference between the highest and the second highest Gross enrolment ratio (%) in Primary schools?
Your answer should be very brief. 3. What is the difference between the highest and the second highest Gross enrolment ratio (%) in Secondary schools?
Ensure brevity in your answer.  13.65. What is the difference between the highest and the second highest Gross enrolment ratio (%) in Tertiary schools?
Offer a terse response. 3.04. What is the difference between the highest and the lowest Gross enrolment ratio (%) of Pre-primary schools?
Provide a short and direct response. 65.31. What is the difference between the highest and the lowest Gross enrolment ratio (%) in Primary schools?
Offer a very short reply. 51.68. What is the difference between the highest and the lowest Gross enrolment ratio (%) of Secondary schools?
Give a very brief answer. 92.4. What is the difference between the highest and the lowest Gross enrolment ratio (%) of Tertiary schools?
Offer a terse response. 32.07. 